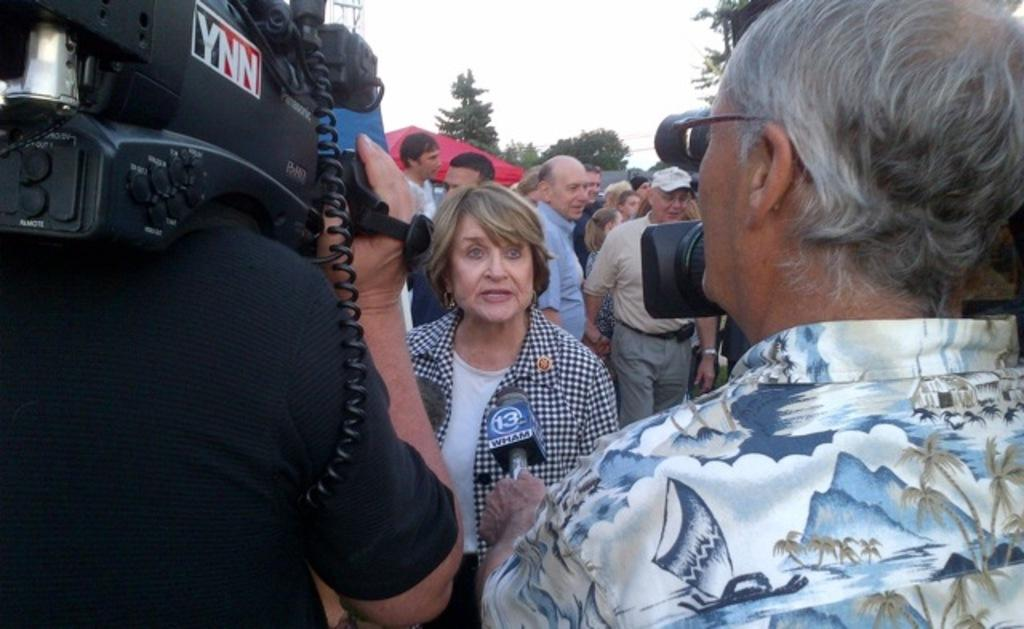What is the person on the left side of the image holding? The person on the left side of the image is holding a camera. What is the person on the right side of the image holding? The person on the right side of the image is holding a microphone. How many people are visible in the image? There are other people in the image besides the person holding the camera and the person holding the microphone. What type of vegetation can be seen in the image? There are trees in the image. What type of bone can be seen in the image? There is no bone present in the image. Is there a tub visible in the image? There is no tub present in the image. 